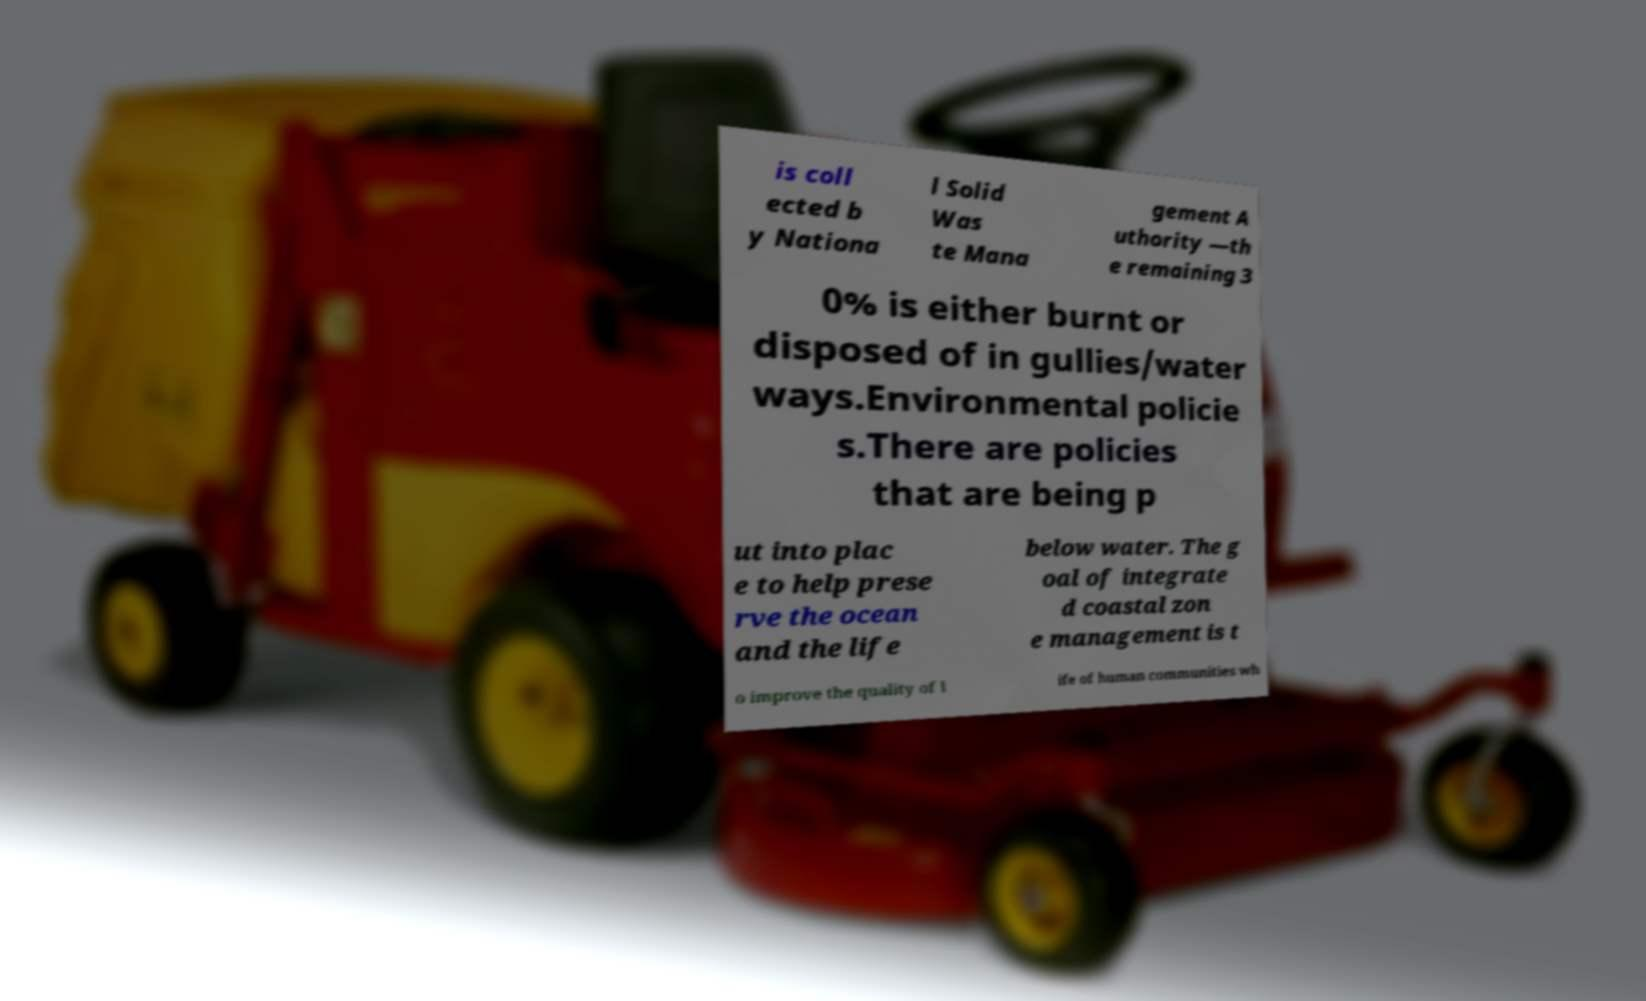There's text embedded in this image that I need extracted. Can you transcribe it verbatim? is coll ected b y Nationa l Solid Was te Mana gement A uthority —th e remaining 3 0% is either burnt or disposed of in gullies/water ways.Environmental policie s.There are policies that are being p ut into plac e to help prese rve the ocean and the life below water. The g oal of integrate d coastal zon e management is t o improve the quality of l ife of human communities wh 